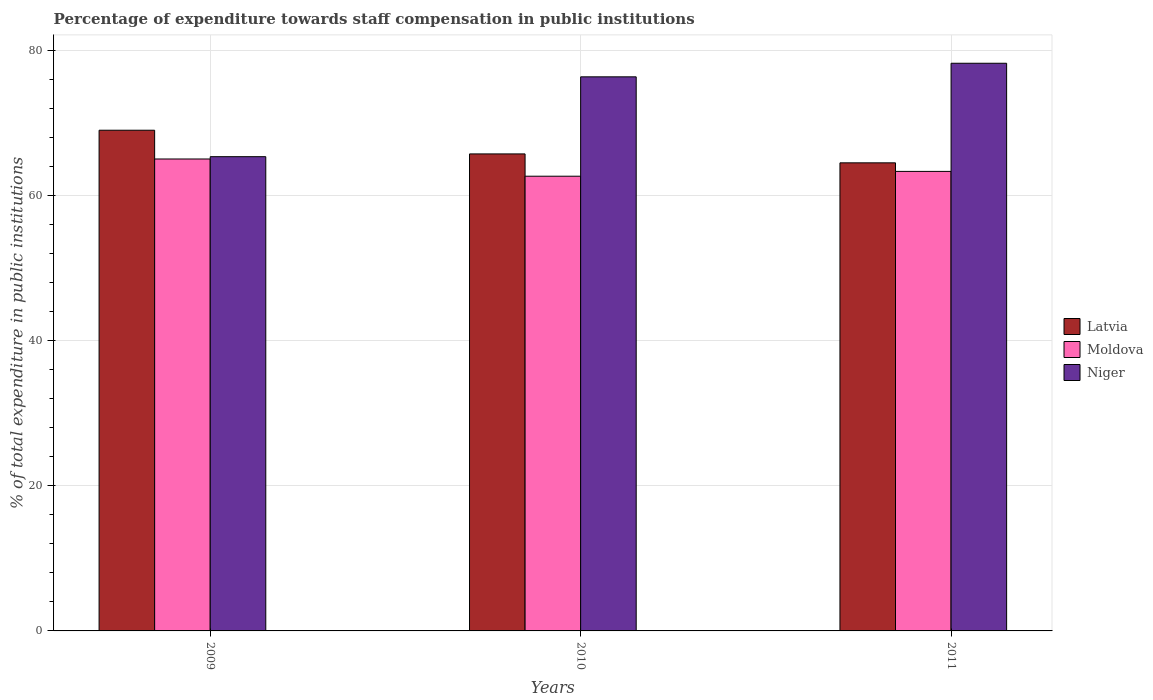How many groups of bars are there?
Your answer should be compact. 3. How many bars are there on the 2nd tick from the left?
Offer a terse response. 3. What is the label of the 2nd group of bars from the left?
Offer a very short reply. 2010. In how many cases, is the number of bars for a given year not equal to the number of legend labels?
Provide a short and direct response. 0. What is the percentage of expenditure towards staff compensation in Latvia in 2011?
Your response must be concise. 64.49. Across all years, what is the maximum percentage of expenditure towards staff compensation in Niger?
Your answer should be very brief. 78.21. Across all years, what is the minimum percentage of expenditure towards staff compensation in Niger?
Provide a succinct answer. 65.34. In which year was the percentage of expenditure towards staff compensation in Niger maximum?
Provide a succinct answer. 2011. In which year was the percentage of expenditure towards staff compensation in Latvia minimum?
Your response must be concise. 2011. What is the total percentage of expenditure towards staff compensation in Moldova in the graph?
Your response must be concise. 190.98. What is the difference between the percentage of expenditure towards staff compensation in Latvia in 2010 and that in 2011?
Make the answer very short. 1.23. What is the difference between the percentage of expenditure towards staff compensation in Latvia in 2010 and the percentage of expenditure towards staff compensation in Niger in 2009?
Your answer should be very brief. 0.38. What is the average percentage of expenditure towards staff compensation in Latvia per year?
Offer a terse response. 66.4. In the year 2009, what is the difference between the percentage of expenditure towards staff compensation in Niger and percentage of expenditure towards staff compensation in Latvia?
Give a very brief answer. -3.64. What is the ratio of the percentage of expenditure towards staff compensation in Latvia in 2009 to that in 2010?
Offer a terse response. 1.05. Is the percentage of expenditure towards staff compensation in Latvia in 2009 less than that in 2010?
Offer a terse response. No. What is the difference between the highest and the second highest percentage of expenditure towards staff compensation in Niger?
Offer a terse response. 1.87. What is the difference between the highest and the lowest percentage of expenditure towards staff compensation in Niger?
Provide a short and direct response. 12.87. In how many years, is the percentage of expenditure towards staff compensation in Latvia greater than the average percentage of expenditure towards staff compensation in Latvia taken over all years?
Make the answer very short. 1. What does the 1st bar from the left in 2009 represents?
Ensure brevity in your answer.  Latvia. What does the 2nd bar from the right in 2009 represents?
Provide a short and direct response. Moldova. Is it the case that in every year, the sum of the percentage of expenditure towards staff compensation in Latvia and percentage of expenditure towards staff compensation in Moldova is greater than the percentage of expenditure towards staff compensation in Niger?
Ensure brevity in your answer.  Yes. How many bars are there?
Make the answer very short. 9. Are all the bars in the graph horizontal?
Your answer should be very brief. No. How many years are there in the graph?
Your response must be concise. 3. What is the difference between two consecutive major ticks on the Y-axis?
Ensure brevity in your answer.  20. Does the graph contain any zero values?
Your answer should be compact. No. Where does the legend appear in the graph?
Give a very brief answer. Center right. How many legend labels are there?
Your answer should be very brief. 3. What is the title of the graph?
Give a very brief answer. Percentage of expenditure towards staff compensation in public institutions. What is the label or title of the X-axis?
Provide a short and direct response. Years. What is the label or title of the Y-axis?
Offer a terse response. % of total expenditure in public institutions. What is the % of total expenditure in public institutions in Latvia in 2009?
Make the answer very short. 68.98. What is the % of total expenditure in public institutions of Moldova in 2009?
Provide a short and direct response. 65.02. What is the % of total expenditure in public institutions in Niger in 2009?
Your response must be concise. 65.34. What is the % of total expenditure in public institutions in Latvia in 2010?
Make the answer very short. 65.72. What is the % of total expenditure in public institutions of Moldova in 2010?
Offer a very short reply. 62.65. What is the % of total expenditure in public institutions in Niger in 2010?
Your response must be concise. 76.34. What is the % of total expenditure in public institutions of Latvia in 2011?
Keep it short and to the point. 64.49. What is the % of total expenditure in public institutions in Moldova in 2011?
Ensure brevity in your answer.  63.31. What is the % of total expenditure in public institutions of Niger in 2011?
Keep it short and to the point. 78.21. Across all years, what is the maximum % of total expenditure in public institutions in Latvia?
Offer a very short reply. 68.98. Across all years, what is the maximum % of total expenditure in public institutions of Moldova?
Make the answer very short. 65.02. Across all years, what is the maximum % of total expenditure in public institutions in Niger?
Your answer should be compact. 78.21. Across all years, what is the minimum % of total expenditure in public institutions of Latvia?
Keep it short and to the point. 64.49. Across all years, what is the minimum % of total expenditure in public institutions in Moldova?
Ensure brevity in your answer.  62.65. Across all years, what is the minimum % of total expenditure in public institutions of Niger?
Your response must be concise. 65.34. What is the total % of total expenditure in public institutions in Latvia in the graph?
Your answer should be compact. 199.19. What is the total % of total expenditure in public institutions in Moldova in the graph?
Your response must be concise. 190.98. What is the total % of total expenditure in public institutions in Niger in the graph?
Provide a succinct answer. 219.89. What is the difference between the % of total expenditure in public institutions of Latvia in 2009 and that in 2010?
Your answer should be very brief. 3.26. What is the difference between the % of total expenditure in public institutions in Moldova in 2009 and that in 2010?
Your answer should be very brief. 2.37. What is the difference between the % of total expenditure in public institutions of Niger in 2009 and that in 2010?
Make the answer very short. -11. What is the difference between the % of total expenditure in public institutions in Latvia in 2009 and that in 2011?
Provide a succinct answer. 4.49. What is the difference between the % of total expenditure in public institutions in Moldova in 2009 and that in 2011?
Keep it short and to the point. 1.71. What is the difference between the % of total expenditure in public institutions of Niger in 2009 and that in 2011?
Provide a succinct answer. -12.87. What is the difference between the % of total expenditure in public institutions in Latvia in 2010 and that in 2011?
Provide a succinct answer. 1.23. What is the difference between the % of total expenditure in public institutions in Moldova in 2010 and that in 2011?
Offer a terse response. -0.66. What is the difference between the % of total expenditure in public institutions in Niger in 2010 and that in 2011?
Offer a very short reply. -1.87. What is the difference between the % of total expenditure in public institutions in Latvia in 2009 and the % of total expenditure in public institutions in Moldova in 2010?
Ensure brevity in your answer.  6.34. What is the difference between the % of total expenditure in public institutions of Latvia in 2009 and the % of total expenditure in public institutions of Niger in 2010?
Give a very brief answer. -7.36. What is the difference between the % of total expenditure in public institutions of Moldova in 2009 and the % of total expenditure in public institutions of Niger in 2010?
Provide a succinct answer. -11.32. What is the difference between the % of total expenditure in public institutions in Latvia in 2009 and the % of total expenditure in public institutions in Moldova in 2011?
Give a very brief answer. 5.67. What is the difference between the % of total expenditure in public institutions of Latvia in 2009 and the % of total expenditure in public institutions of Niger in 2011?
Offer a terse response. -9.23. What is the difference between the % of total expenditure in public institutions of Moldova in 2009 and the % of total expenditure in public institutions of Niger in 2011?
Your answer should be very brief. -13.19. What is the difference between the % of total expenditure in public institutions of Latvia in 2010 and the % of total expenditure in public institutions of Moldova in 2011?
Ensure brevity in your answer.  2.41. What is the difference between the % of total expenditure in public institutions of Latvia in 2010 and the % of total expenditure in public institutions of Niger in 2011?
Make the answer very short. -12.49. What is the difference between the % of total expenditure in public institutions of Moldova in 2010 and the % of total expenditure in public institutions of Niger in 2011?
Your response must be concise. -15.56. What is the average % of total expenditure in public institutions in Latvia per year?
Ensure brevity in your answer.  66.4. What is the average % of total expenditure in public institutions of Moldova per year?
Your answer should be very brief. 63.66. What is the average % of total expenditure in public institutions of Niger per year?
Your response must be concise. 73.3. In the year 2009, what is the difference between the % of total expenditure in public institutions in Latvia and % of total expenditure in public institutions in Moldova?
Make the answer very short. 3.96. In the year 2009, what is the difference between the % of total expenditure in public institutions of Latvia and % of total expenditure in public institutions of Niger?
Provide a succinct answer. 3.64. In the year 2009, what is the difference between the % of total expenditure in public institutions of Moldova and % of total expenditure in public institutions of Niger?
Offer a terse response. -0.32. In the year 2010, what is the difference between the % of total expenditure in public institutions in Latvia and % of total expenditure in public institutions in Moldova?
Your answer should be compact. 3.07. In the year 2010, what is the difference between the % of total expenditure in public institutions of Latvia and % of total expenditure in public institutions of Niger?
Offer a terse response. -10.62. In the year 2010, what is the difference between the % of total expenditure in public institutions of Moldova and % of total expenditure in public institutions of Niger?
Provide a succinct answer. -13.69. In the year 2011, what is the difference between the % of total expenditure in public institutions in Latvia and % of total expenditure in public institutions in Moldova?
Keep it short and to the point. 1.18. In the year 2011, what is the difference between the % of total expenditure in public institutions in Latvia and % of total expenditure in public institutions in Niger?
Offer a terse response. -13.72. In the year 2011, what is the difference between the % of total expenditure in public institutions of Moldova and % of total expenditure in public institutions of Niger?
Give a very brief answer. -14.9. What is the ratio of the % of total expenditure in public institutions of Latvia in 2009 to that in 2010?
Ensure brevity in your answer.  1.05. What is the ratio of the % of total expenditure in public institutions in Moldova in 2009 to that in 2010?
Offer a terse response. 1.04. What is the ratio of the % of total expenditure in public institutions of Niger in 2009 to that in 2010?
Ensure brevity in your answer.  0.86. What is the ratio of the % of total expenditure in public institutions in Latvia in 2009 to that in 2011?
Give a very brief answer. 1.07. What is the ratio of the % of total expenditure in public institutions of Moldova in 2009 to that in 2011?
Keep it short and to the point. 1.03. What is the ratio of the % of total expenditure in public institutions in Niger in 2009 to that in 2011?
Your answer should be very brief. 0.84. What is the ratio of the % of total expenditure in public institutions of Niger in 2010 to that in 2011?
Offer a very short reply. 0.98. What is the difference between the highest and the second highest % of total expenditure in public institutions of Latvia?
Offer a very short reply. 3.26. What is the difference between the highest and the second highest % of total expenditure in public institutions in Moldova?
Offer a very short reply. 1.71. What is the difference between the highest and the second highest % of total expenditure in public institutions in Niger?
Your answer should be very brief. 1.87. What is the difference between the highest and the lowest % of total expenditure in public institutions of Latvia?
Your response must be concise. 4.49. What is the difference between the highest and the lowest % of total expenditure in public institutions of Moldova?
Your answer should be compact. 2.37. What is the difference between the highest and the lowest % of total expenditure in public institutions in Niger?
Give a very brief answer. 12.87. 